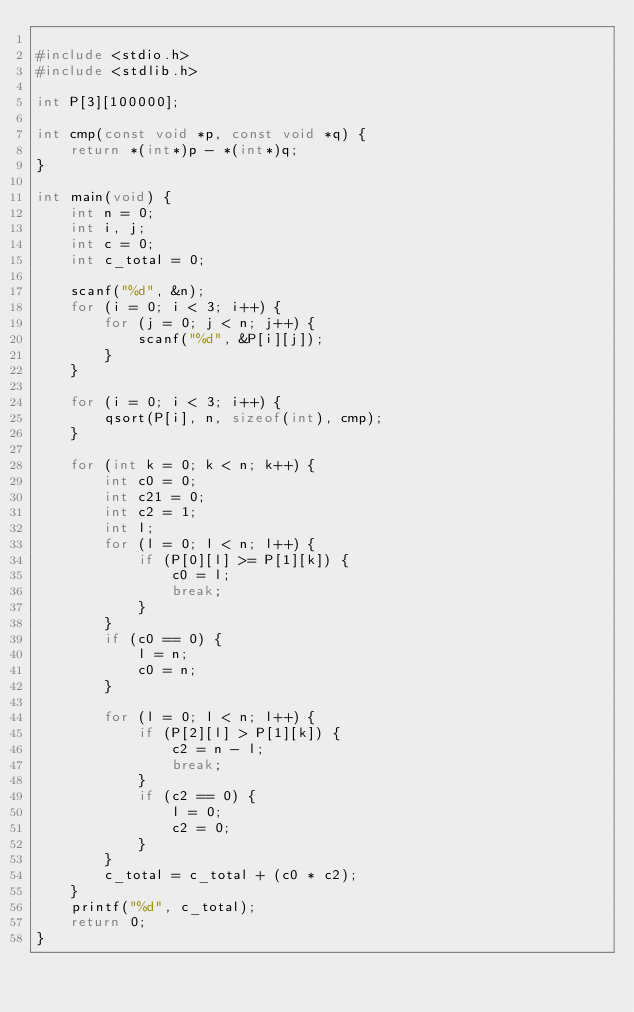<code> <loc_0><loc_0><loc_500><loc_500><_C_>
#include <stdio.h>
#include <stdlib.h>

int P[3][100000];

int cmp(const void *p, const void *q) {
	return *(int*)p - *(int*)q;
}

int main(void) {
	int n = 0;
	int i, j;
	int c = 0;
	int c_total = 0;

	scanf("%d", &n);
	for (i = 0; i < 3; i++) {
		for (j = 0; j < n; j++) {
			scanf("%d", &P[i][j]);
		}
	}

	for (i = 0; i < 3; i++) {
		qsort(P[i], n, sizeof(int), cmp);
	}

	for (int k = 0; k < n; k++) {
		int c0 = 0;
		int c21 = 0;
		int c2 = 1;
		int l;
		for (l = 0; l < n; l++) {
			if (P[0][l] >= P[1][k]) { 
				c0 = l;
				break;
			}
		}
		if (c0 == 0) {
			l = n;
			c0 = n;
		}

		for (l = 0; l < n; l++) {
			if (P[2][l] > P[1][k]) {
				c2 = n - l; 
				break;
			}
			if (c2 == 0) {
				l = 0;
				c2 = 0;
			}
		}
		c_total = c_total + (c0 * c2);
	}
	printf("%d", c_total);
	return 0;
}</code> 